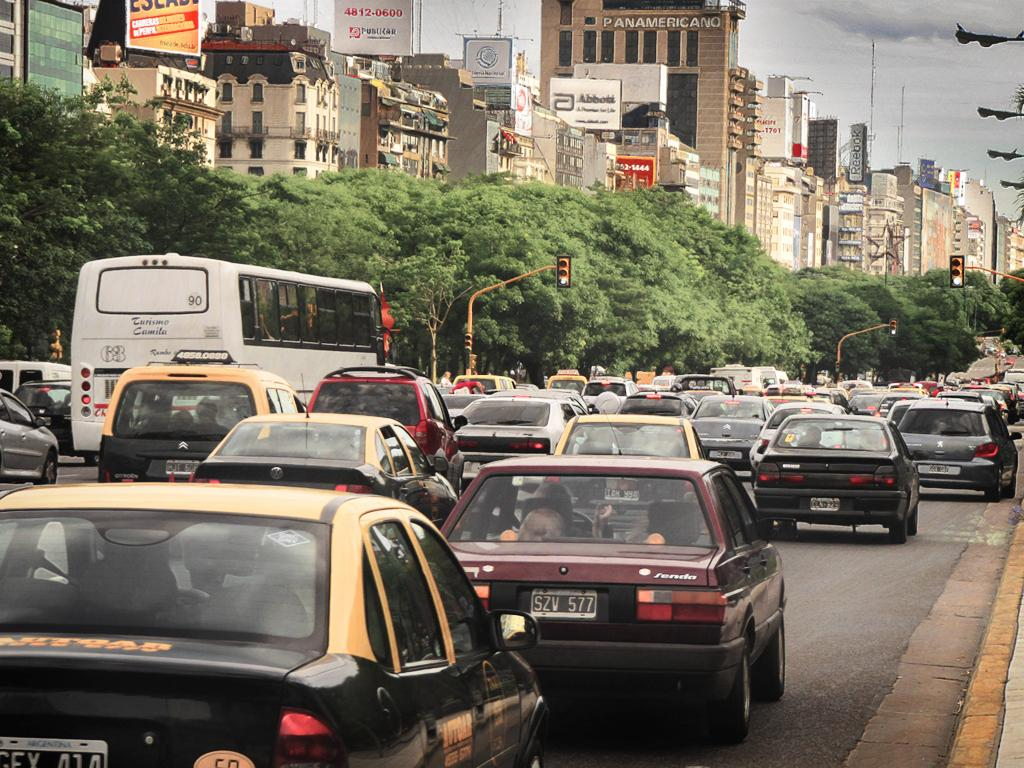<image>
Offer a succinct explanation of the picture presented. A busy street with a building that says Panamericano in the background. 